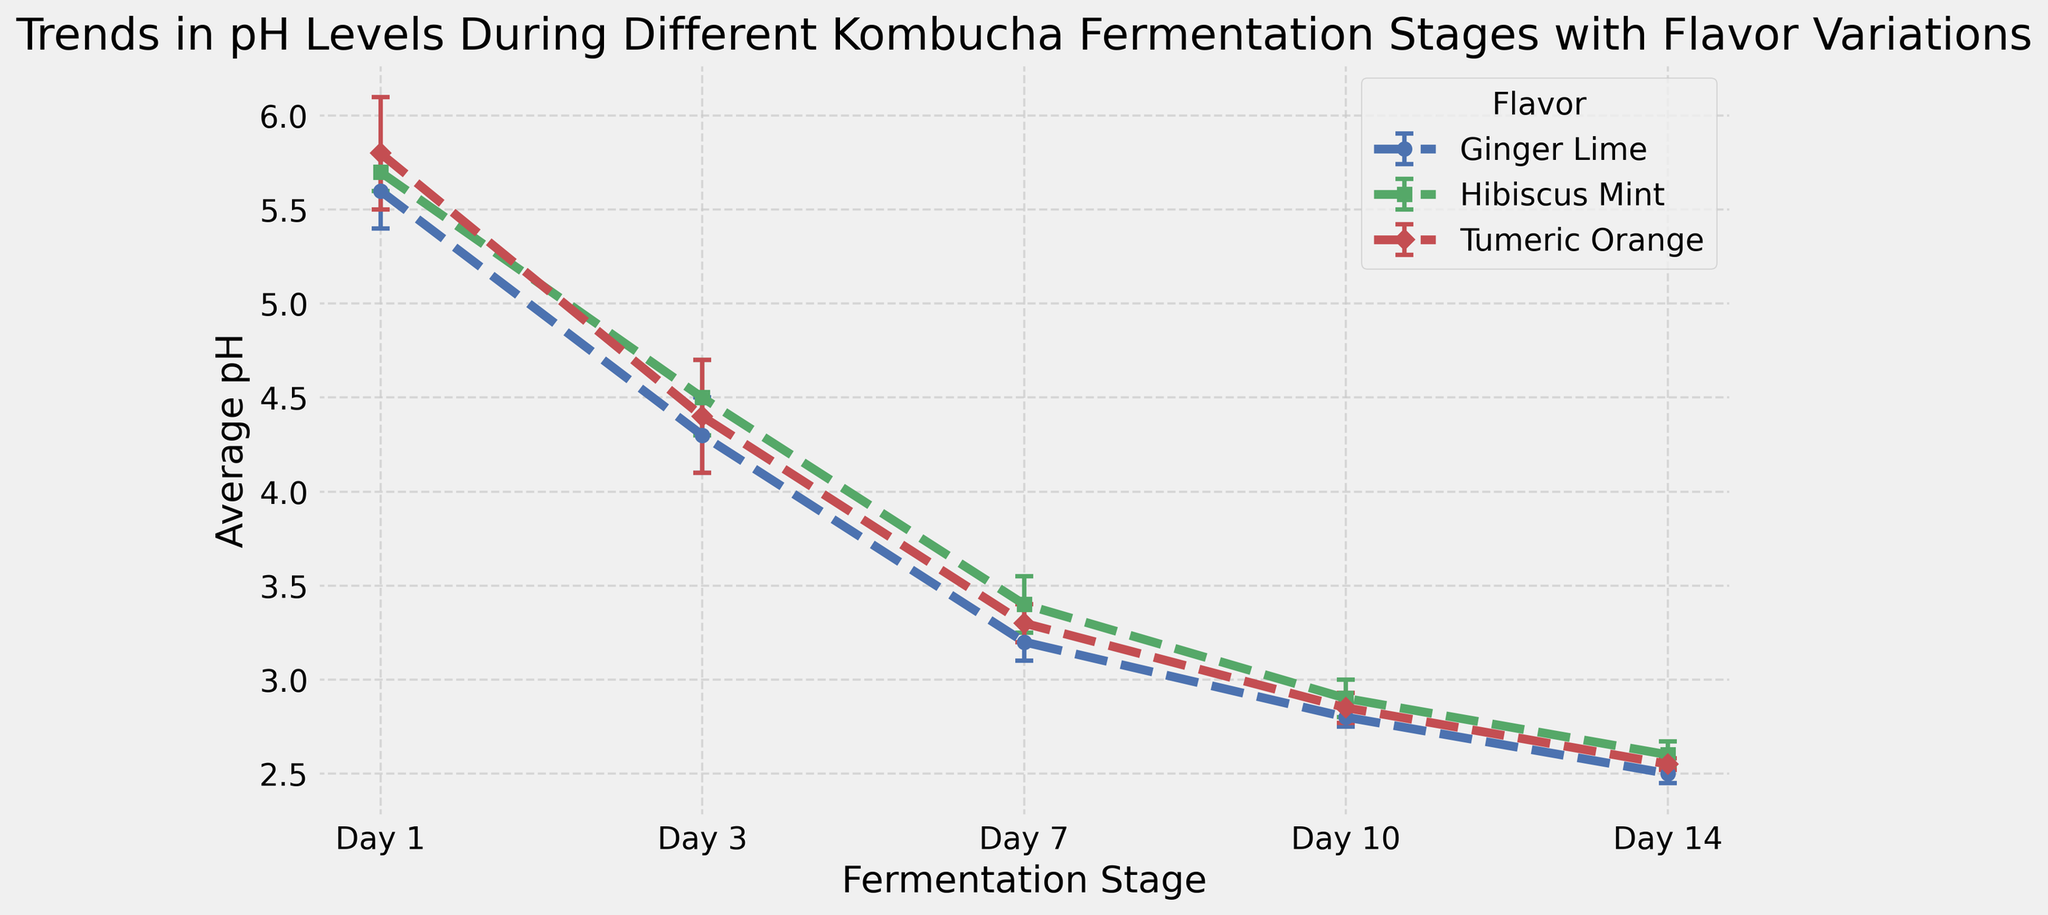How does the average pH level of Ginger Lime change from Day 1 to Day 14? Observe the average pH levels of Ginger Lime for each fermentation stage: 5.6 (Day 1), 4.3 (Day 3), 3.2 (Day 7), 2.8 (Day 10), 2.5 (Day 14). Notice that the average pH level decreases consistently from Day 1 to Day 14.
Answer: The average pH level decreases Which flavor has the highest pH level on Day 1? Compare the average pH levels of all flavors on Day 1: Ginger Lime (5.6), Hibiscus Mint (5.7), Tumeric Orange (5.8). Tumeric Orange has the highest pH.
Answer: Tumeric Orange By how much does the pH level of Hibiscus Mint decrease between Day 3 and Day 10? Note the average pH levels of Hibiscus Mint on Day 3 (4.5) and Day 10 (2.9). Subtract 2.9 from 4.5 to find the difference: 4.5 - 2.9.
Answer: 1.6 Which flavor exhibits the largest variation (standard deviation) in pH levels on Day 3? Check the standard deviations for each flavor on Day 3: Ginger Lime (0.2), Hibiscus Mint (0.2), Tumeric Orange (0.3). Tumeric Orange has the highest standard deviation.
Answer: Tumeric Orange On what day does Ginger Lime reach a pH level below 3? Observe the pH levels of Ginger Lime: 5.6 (Day 1), 4.3 (Day 3), 3.2 (Day 7), 2.8 (Day 10), 2.5 (Day 14). The pH level drops below 3 on Day 7.
Answer: Day 7 Which flavor experiences the smallest change in average pH from Day 7 to Day 10? Note the average pH levels for each flavor on Day 7 and Day 10. Calculate the changes: Ginger Lime: 3.2 to 2.8 (0.4), Hibiscus Mint: 3.4 to 2.9 (0.5), Tumeric Orange: 3.3 to 2.85 (0.45). Ginger Lime has the smallest change.
Answer: Ginger Lime Is there a flavor that shows an increase in pH level at any stage? Scan the trend lines for each flavor; all lines show a consistent decrease in pH levels across the fermentation stages. No flavor shows an increase.
Answer: No What is the relative position of error bars for Hibiscus Mint compared to other flavors on Day 7? Compare the lengths of error bars on Day 7: Hibiscus Mint (0.15), Ginger Lime (0.1), Tumeric Orange (0.1). Hibiscus Mint has longer error bars indicating more variability.
Answer: Longer than others 